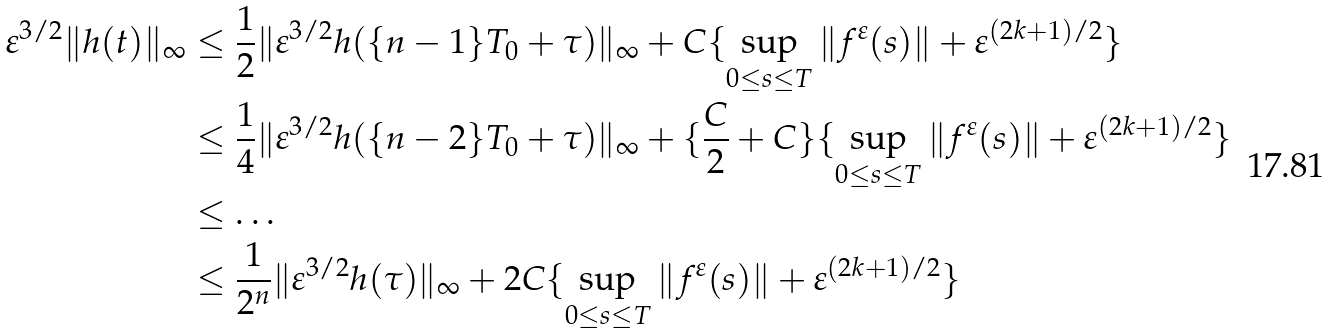<formula> <loc_0><loc_0><loc_500><loc_500>\varepsilon ^ { 3 / 2 } \| h ( t ) \| _ { \infty } & \leq \frac { 1 } { 2 } \| \varepsilon ^ { 3 / 2 } h ( \{ n - 1 \} T _ { 0 } + \tau ) \| _ { \infty } + C \{ \sup _ { 0 \leq s \leq T } \| f ^ { \varepsilon } ( s ) \| + \varepsilon ^ { ( 2 k + 1 ) / 2 } \} \\ & \leq \frac { 1 } { 4 } \| \varepsilon ^ { 3 / 2 } h ( \{ n - 2 \} T _ { 0 } + \tau ) \| _ { \infty } + \{ \frac { C } { 2 } + C \} \{ \sup _ { 0 \leq s \leq T } \| f ^ { \varepsilon } ( s ) \| + \varepsilon ^ { ( 2 k + 1 ) / 2 } \} \\ & \leq \dots \\ & \leq \frac { 1 } { 2 ^ { n } } \| \varepsilon ^ { 3 / 2 } h ( \tau ) \| _ { \infty } + 2 C \{ \sup _ { 0 \leq s \leq T } \| f ^ { \varepsilon } ( s ) \| + \varepsilon ^ { ( 2 k + 1 ) / 2 } \}</formula> 